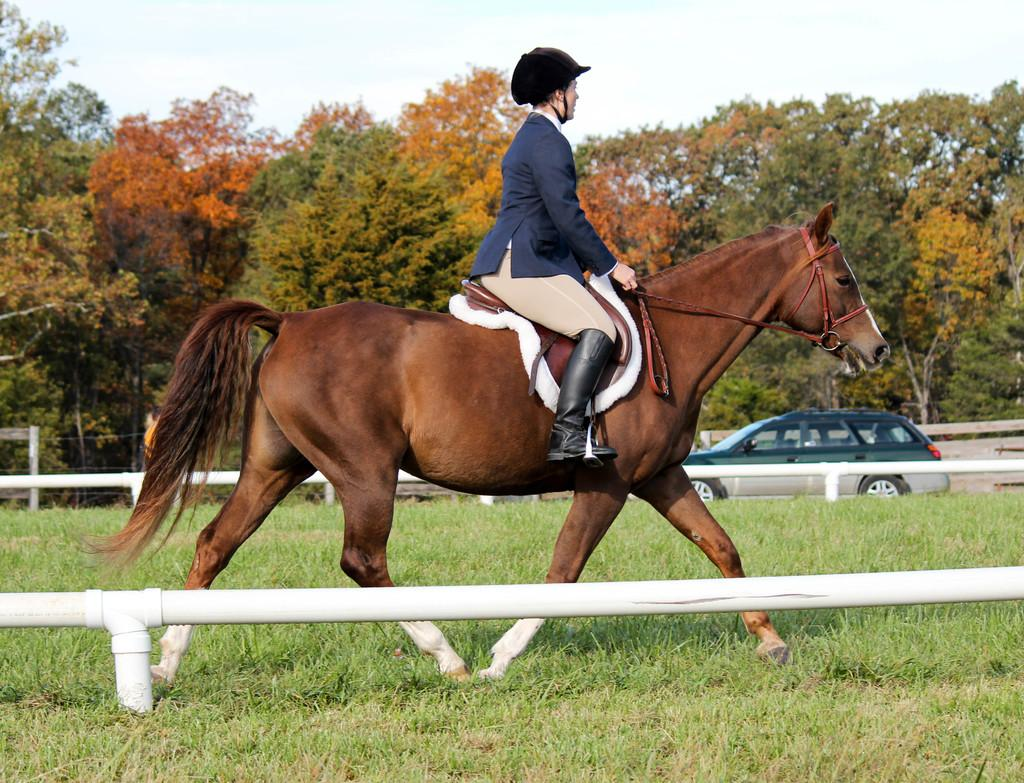What is the person in the image doing? The person is riding a horse. What is the ground made of in the image? The ground is covered in grass. What can be seen on the road in the image? There is a vehicle on the road. What type of vegetation is visible in the image? There are trees visible. What is visible in the background of the image? The sky is visible in the background. What object is present in the image that is not easily identifiable? There is a rod in the image, although its context or purpose is unclear. Can you see the limit of the sea in the image? There is no sea present in the image, so it is not possible to see its limit. 